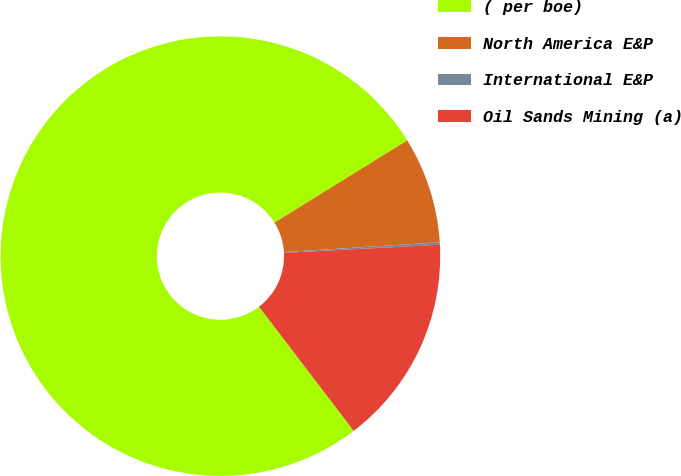Convert chart to OTSL. <chart><loc_0><loc_0><loc_500><loc_500><pie_chart><fcel>( per boe)<fcel>North America E&P<fcel>International E&P<fcel>Oil Sands Mining (a)<nl><fcel>76.54%<fcel>7.82%<fcel>0.18%<fcel>15.45%<nl></chart> 